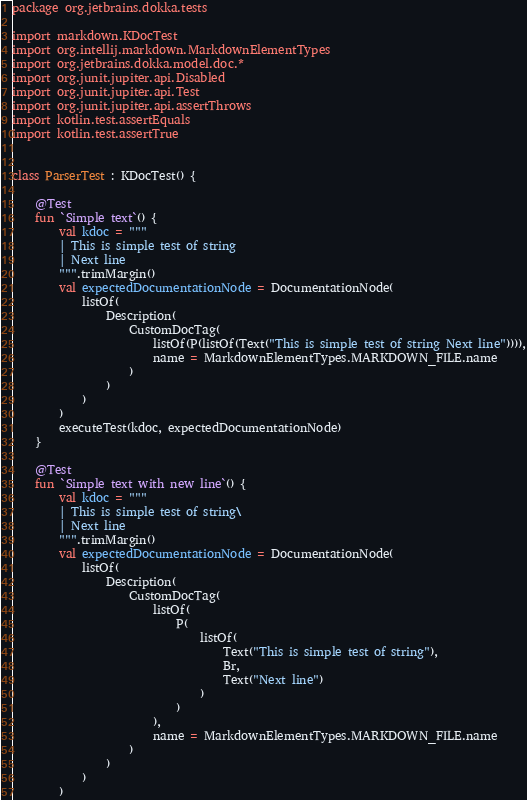Convert code to text. <code><loc_0><loc_0><loc_500><loc_500><_Kotlin_>package org.jetbrains.dokka.tests

import markdown.KDocTest
import org.intellij.markdown.MarkdownElementTypes
import org.jetbrains.dokka.model.doc.*
import org.junit.jupiter.api.Disabled
import org.junit.jupiter.api.Test
import org.junit.jupiter.api.assertThrows
import kotlin.test.assertEquals
import kotlin.test.assertTrue


class ParserTest : KDocTest() {

    @Test
    fun `Simple text`() {
        val kdoc = """
        | This is simple test of string
        | Next line
        """.trimMargin()
        val expectedDocumentationNode = DocumentationNode(
            listOf(
                Description(
                    CustomDocTag(
                        listOf(P(listOf(Text("This is simple test of string Next line")))),
                        name = MarkdownElementTypes.MARKDOWN_FILE.name
                    )
                )
            )
        )
        executeTest(kdoc, expectedDocumentationNode)
    }

    @Test
    fun `Simple text with new line`() {
        val kdoc = """
        | This is simple test of string\
        | Next line
        """.trimMargin()
        val expectedDocumentationNode = DocumentationNode(
            listOf(
                Description(
                    CustomDocTag(
                        listOf(
                            P(
                                listOf(
                                    Text("This is simple test of string"),
                                    Br,
                                    Text("Next line")
                                )
                            )
                        ),
                        name = MarkdownElementTypes.MARKDOWN_FILE.name
                    )
                )
            )
        )</code> 